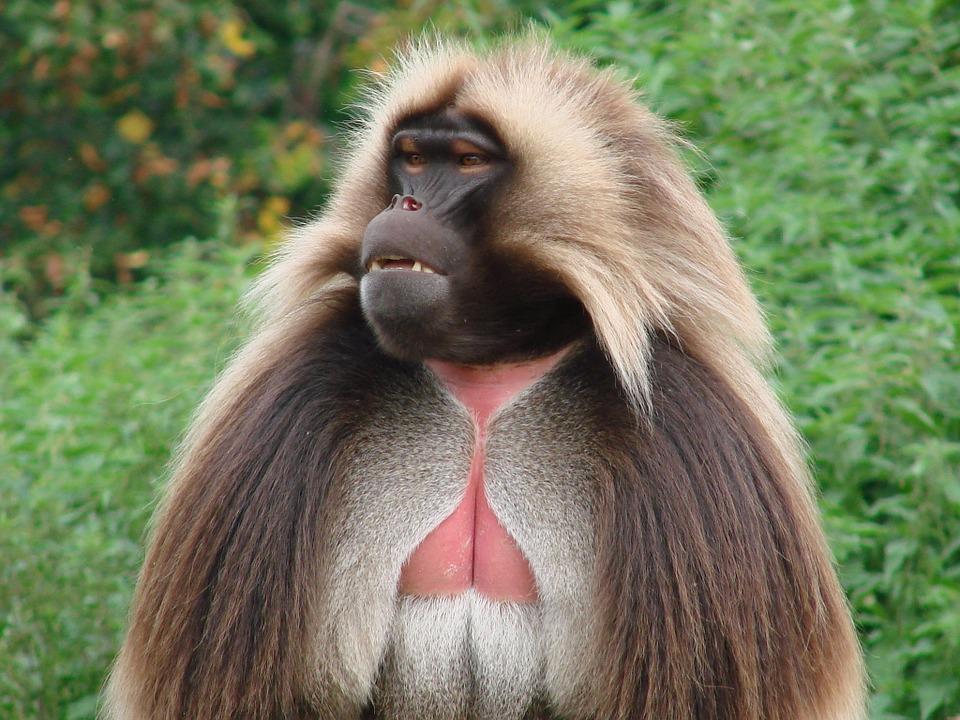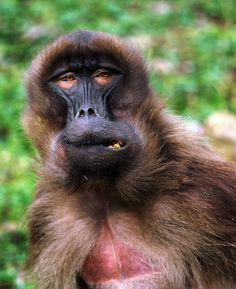The first image is the image on the left, the second image is the image on the right. For the images displayed, is the sentence "The feet of the adult monkey can be seen in the image on the left." factually correct? Answer yes or no. No. 